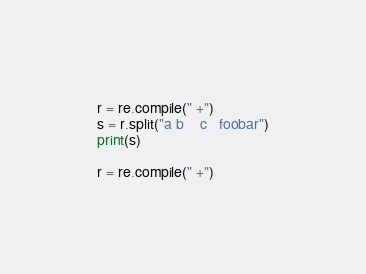<code> <loc_0><loc_0><loc_500><loc_500><_Python_>
r = re.compile(" +")
s = r.split("a b    c   foobar")
print(s)

r = re.compile(" +")</code> 